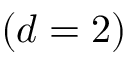<formula> <loc_0><loc_0><loc_500><loc_500>( d = 2 )</formula> 